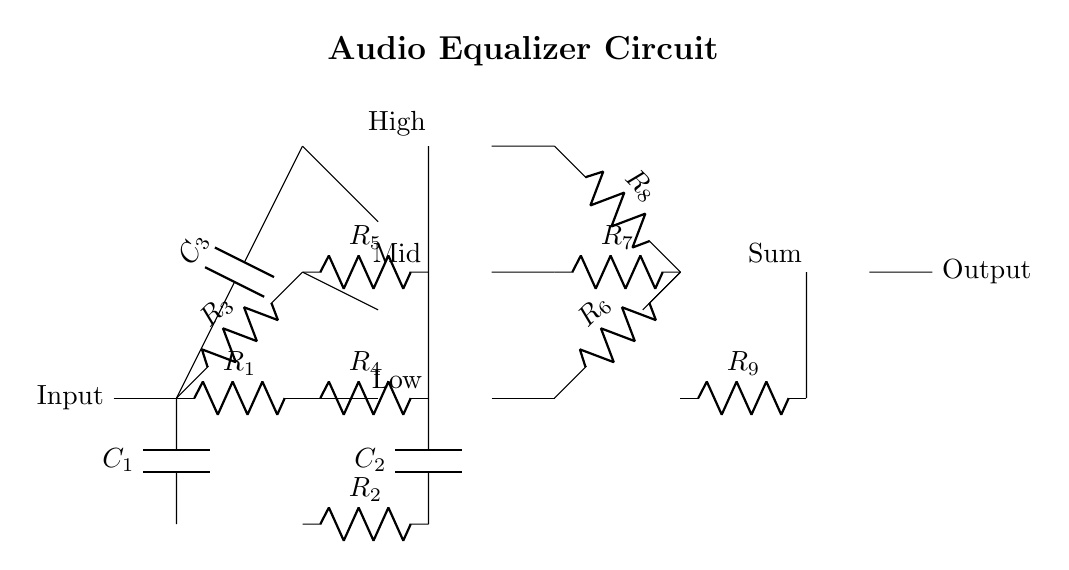What components are used in the low-frequency branch? The low-frequency branch includes a resistor labeled R1 and a capacitor labeled C1, as well as an op-amp.
Answer: R1, C1, op-amp How many resistors are there in total in the circuit? By counting from the diagram, there are a total of five labeled resistors: R1, R2, R3, R4, R5, R6, R7, R8, and R9. Adding them up gives a total of nine resistors.
Answer: Nine What is the purpose of the operational amplifiers in this circuit? The operational amplifiers function as active components in each frequency branch, providing gain and processing the signals from the input. This allows for more precise sound equalization.
Answer: Gain Which component connects the low, mid, and high frequency branches to the output? The component that connects the branches to the output is an additional op-amp, which sums the outputs from the three branches before sending it out as a single output signal.
Answer: Op-amp What is the role of capacitors in this equalizer circuit? Capacitors (C1, C2, and C3) are utilized to filter frequency signals by blocking direct current (DC) and allowing alternating current (AC) signals, which is essential for equalizing sound.
Answer: Filtering How are the output signals combined in this audio equalizer circuit? The output signals from each of the three op-amps in low, mid, and high frequency branches converge to the summing point through resistors R6, R7, and R8 before going to the final output op-amp.
Answer: Through summing 